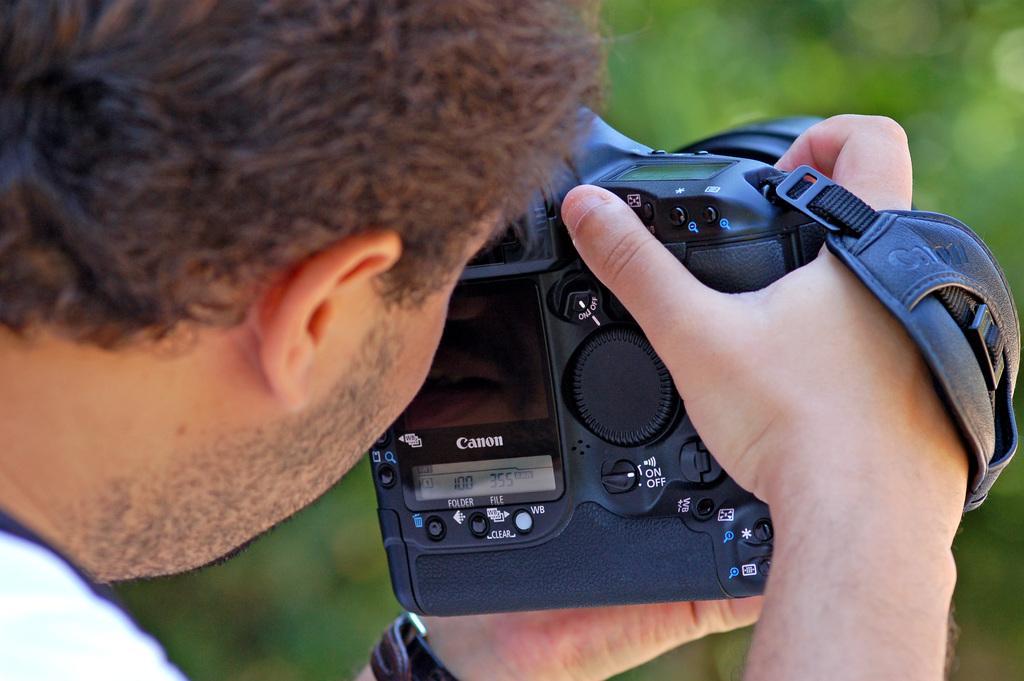In one or two sentences, can you explain what this image depicts? A man is taking picture with a camera in his hand. The brand of the camera is canon. 